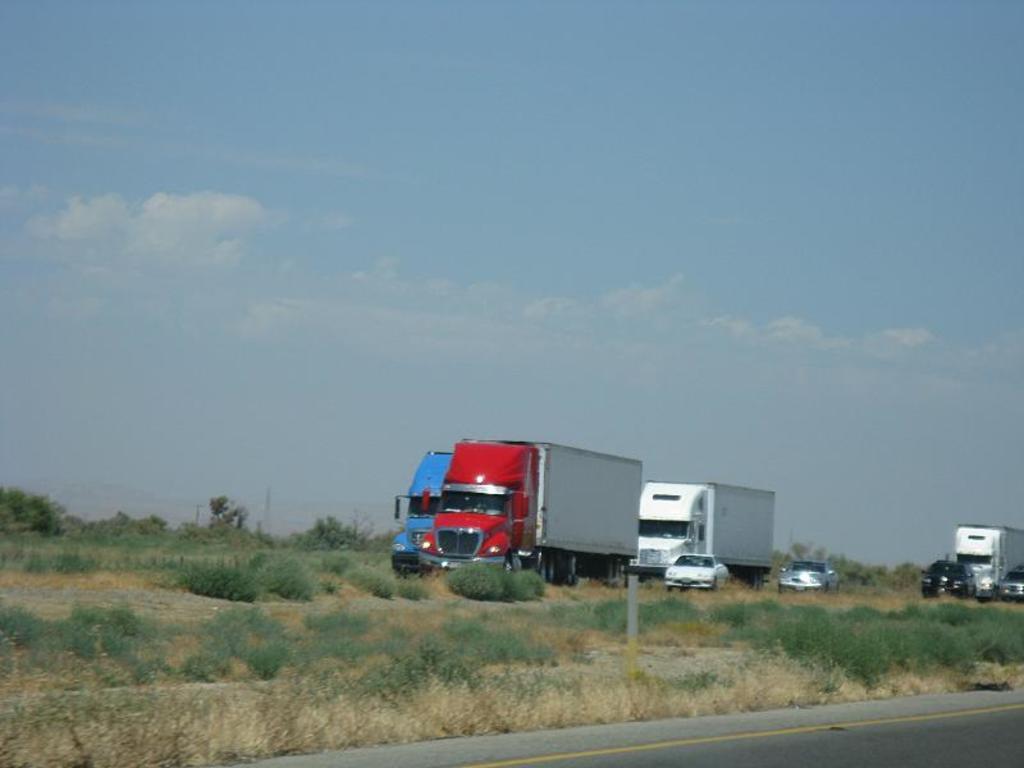Please provide a concise description of this image. In this image, we can see few vehicles, plants, pole and trees. At the bottom, there is a road with yellow line. Background there is a sky. 